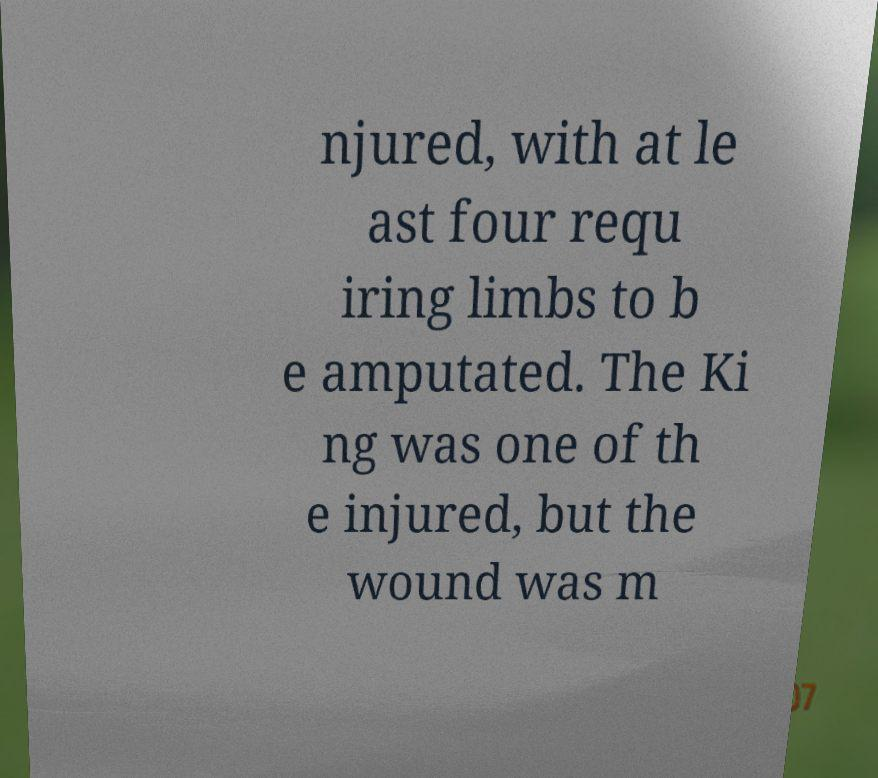For documentation purposes, I need the text within this image transcribed. Could you provide that? njured, with at le ast four requ iring limbs to b e amputated. The Ki ng was one of th e injured, but the wound was m 